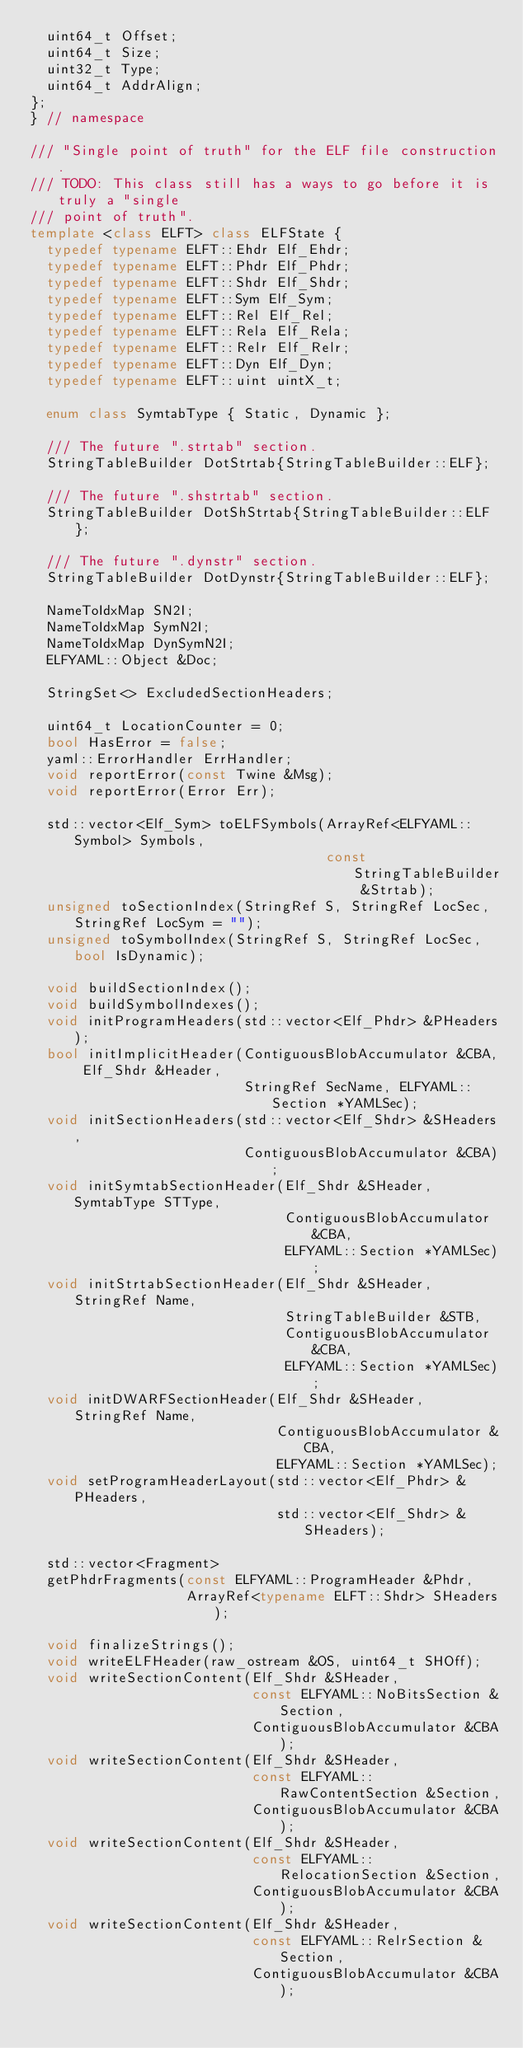<code> <loc_0><loc_0><loc_500><loc_500><_C++_>  uint64_t Offset;
  uint64_t Size;
  uint32_t Type;
  uint64_t AddrAlign;
};
} // namespace

/// "Single point of truth" for the ELF file construction.
/// TODO: This class still has a ways to go before it is truly a "single
/// point of truth".
template <class ELFT> class ELFState {
  typedef typename ELFT::Ehdr Elf_Ehdr;
  typedef typename ELFT::Phdr Elf_Phdr;
  typedef typename ELFT::Shdr Elf_Shdr;
  typedef typename ELFT::Sym Elf_Sym;
  typedef typename ELFT::Rel Elf_Rel;
  typedef typename ELFT::Rela Elf_Rela;
  typedef typename ELFT::Relr Elf_Relr;
  typedef typename ELFT::Dyn Elf_Dyn;
  typedef typename ELFT::uint uintX_t;

  enum class SymtabType { Static, Dynamic };

  /// The future ".strtab" section.
  StringTableBuilder DotStrtab{StringTableBuilder::ELF};

  /// The future ".shstrtab" section.
  StringTableBuilder DotShStrtab{StringTableBuilder::ELF};

  /// The future ".dynstr" section.
  StringTableBuilder DotDynstr{StringTableBuilder::ELF};

  NameToIdxMap SN2I;
  NameToIdxMap SymN2I;
  NameToIdxMap DynSymN2I;
  ELFYAML::Object &Doc;

  StringSet<> ExcludedSectionHeaders;

  uint64_t LocationCounter = 0;
  bool HasError = false;
  yaml::ErrorHandler ErrHandler;
  void reportError(const Twine &Msg);
  void reportError(Error Err);

  std::vector<Elf_Sym> toELFSymbols(ArrayRef<ELFYAML::Symbol> Symbols,
                                    const StringTableBuilder &Strtab);
  unsigned toSectionIndex(StringRef S, StringRef LocSec, StringRef LocSym = "");
  unsigned toSymbolIndex(StringRef S, StringRef LocSec, bool IsDynamic);

  void buildSectionIndex();
  void buildSymbolIndexes();
  void initProgramHeaders(std::vector<Elf_Phdr> &PHeaders);
  bool initImplicitHeader(ContiguousBlobAccumulator &CBA, Elf_Shdr &Header,
                          StringRef SecName, ELFYAML::Section *YAMLSec);
  void initSectionHeaders(std::vector<Elf_Shdr> &SHeaders,
                          ContiguousBlobAccumulator &CBA);
  void initSymtabSectionHeader(Elf_Shdr &SHeader, SymtabType STType,
                               ContiguousBlobAccumulator &CBA,
                               ELFYAML::Section *YAMLSec);
  void initStrtabSectionHeader(Elf_Shdr &SHeader, StringRef Name,
                               StringTableBuilder &STB,
                               ContiguousBlobAccumulator &CBA,
                               ELFYAML::Section *YAMLSec);
  void initDWARFSectionHeader(Elf_Shdr &SHeader, StringRef Name,
                              ContiguousBlobAccumulator &CBA,
                              ELFYAML::Section *YAMLSec);
  void setProgramHeaderLayout(std::vector<Elf_Phdr> &PHeaders,
                              std::vector<Elf_Shdr> &SHeaders);

  std::vector<Fragment>
  getPhdrFragments(const ELFYAML::ProgramHeader &Phdr,
                   ArrayRef<typename ELFT::Shdr> SHeaders);

  void finalizeStrings();
  void writeELFHeader(raw_ostream &OS, uint64_t SHOff);
  void writeSectionContent(Elf_Shdr &SHeader,
                           const ELFYAML::NoBitsSection &Section,
                           ContiguousBlobAccumulator &CBA);
  void writeSectionContent(Elf_Shdr &SHeader,
                           const ELFYAML::RawContentSection &Section,
                           ContiguousBlobAccumulator &CBA);
  void writeSectionContent(Elf_Shdr &SHeader,
                           const ELFYAML::RelocationSection &Section,
                           ContiguousBlobAccumulator &CBA);
  void writeSectionContent(Elf_Shdr &SHeader,
                           const ELFYAML::RelrSection &Section,
                           ContiguousBlobAccumulator &CBA);</code> 